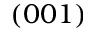<formula> <loc_0><loc_0><loc_500><loc_500>( 0 0 1 )</formula> 